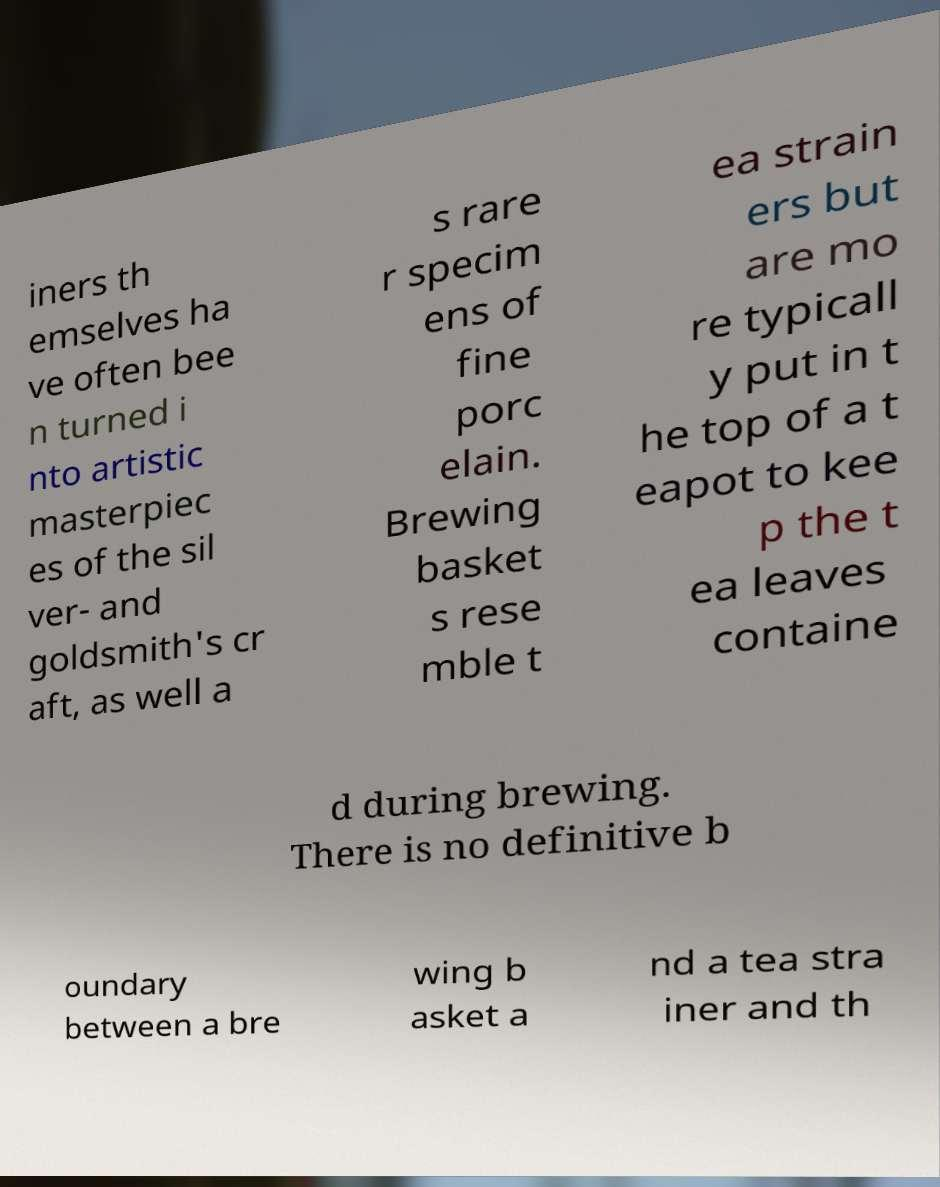Can you read and provide the text displayed in the image?This photo seems to have some interesting text. Can you extract and type it out for me? iners th emselves ha ve often bee n turned i nto artistic masterpiec es of the sil ver- and goldsmith's cr aft, as well a s rare r specim ens of fine porc elain. Brewing basket s rese mble t ea strain ers but are mo re typicall y put in t he top of a t eapot to kee p the t ea leaves containe d during brewing. There is no definitive b oundary between a bre wing b asket a nd a tea stra iner and th 